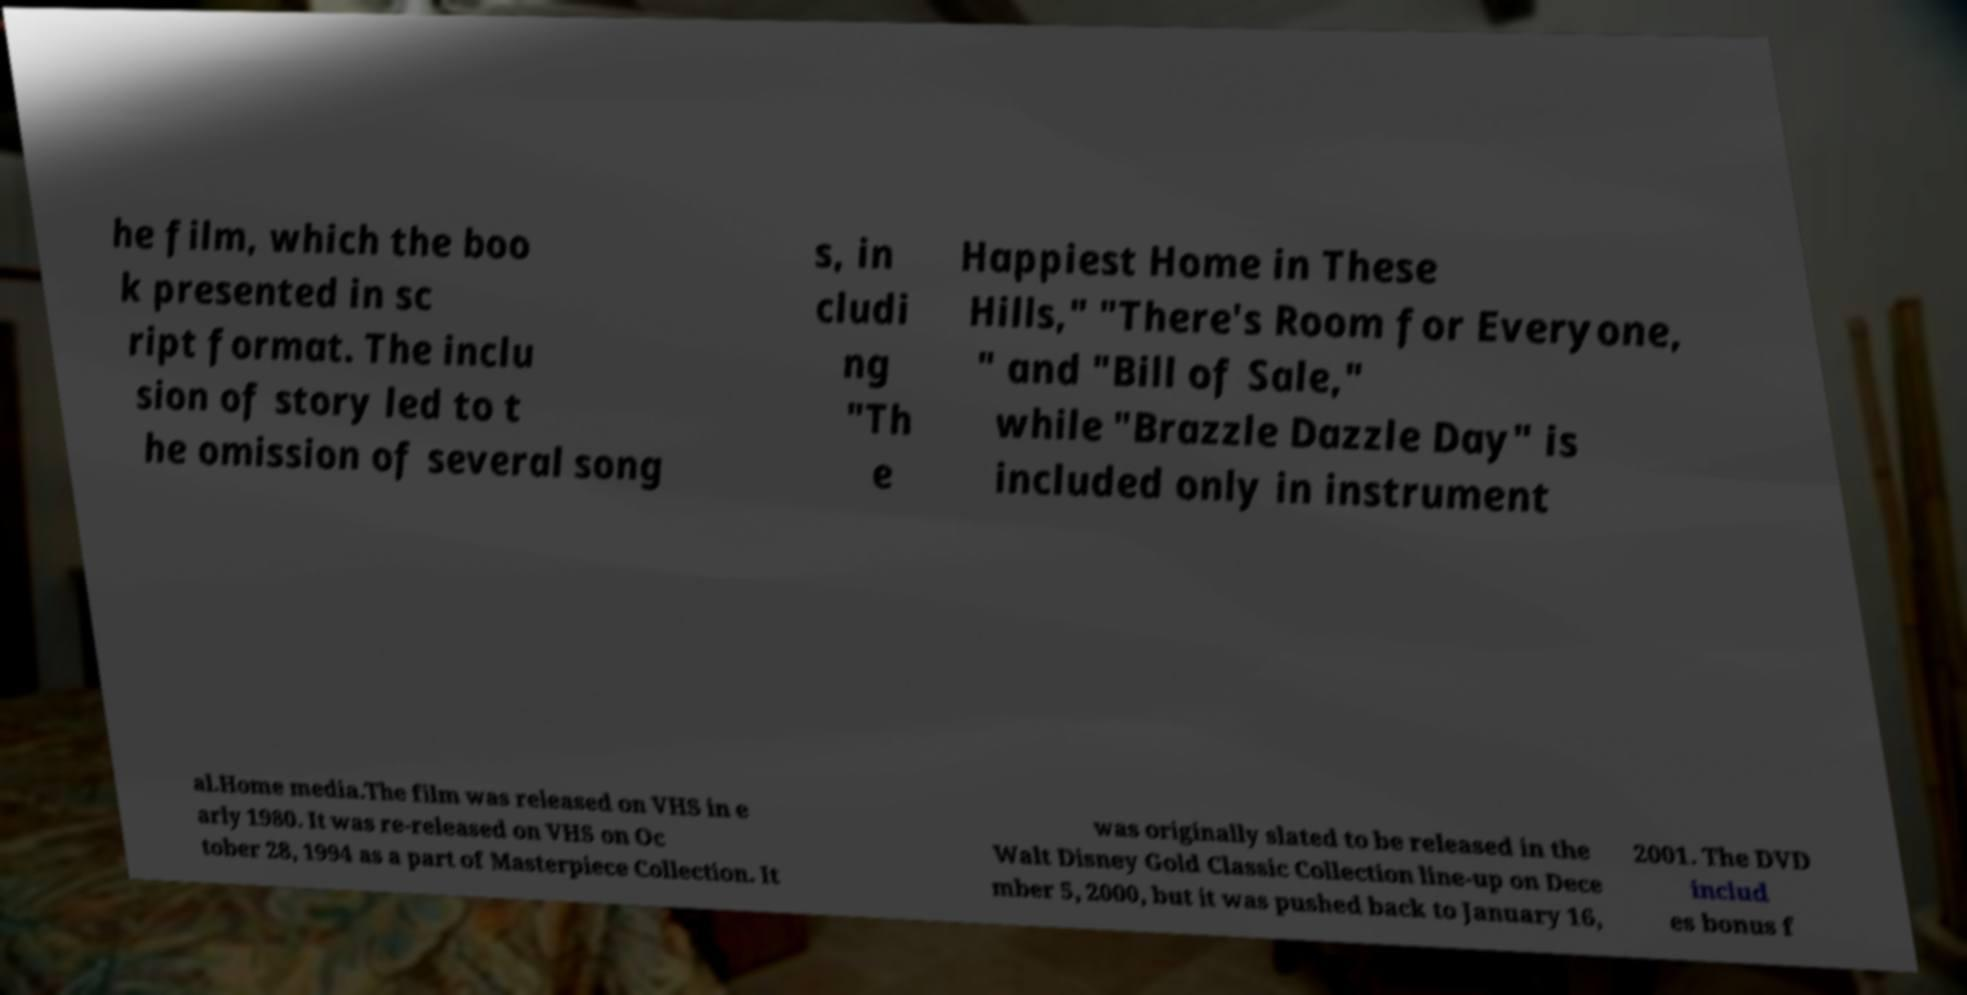Could you extract and type out the text from this image? he film, which the boo k presented in sc ript format. The inclu sion of story led to t he omission of several song s, in cludi ng "Th e Happiest Home in These Hills," "There's Room for Everyone, " and "Bill of Sale," while "Brazzle Dazzle Day" is included only in instrument al.Home media.The film was released on VHS in e arly 1980. It was re-released on VHS on Oc tober 28, 1994 as a part of Masterpiece Collection. It was originally slated to be released in the Walt Disney Gold Classic Collection line-up on Dece mber 5, 2000, but it was pushed back to January 16, 2001. The DVD includ es bonus f 